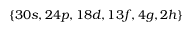<formula> <loc_0><loc_0><loc_500><loc_500>\{ 3 0 s , 2 4 p , 1 8 d , 1 3 f , 4 g , 2 h \}</formula> 